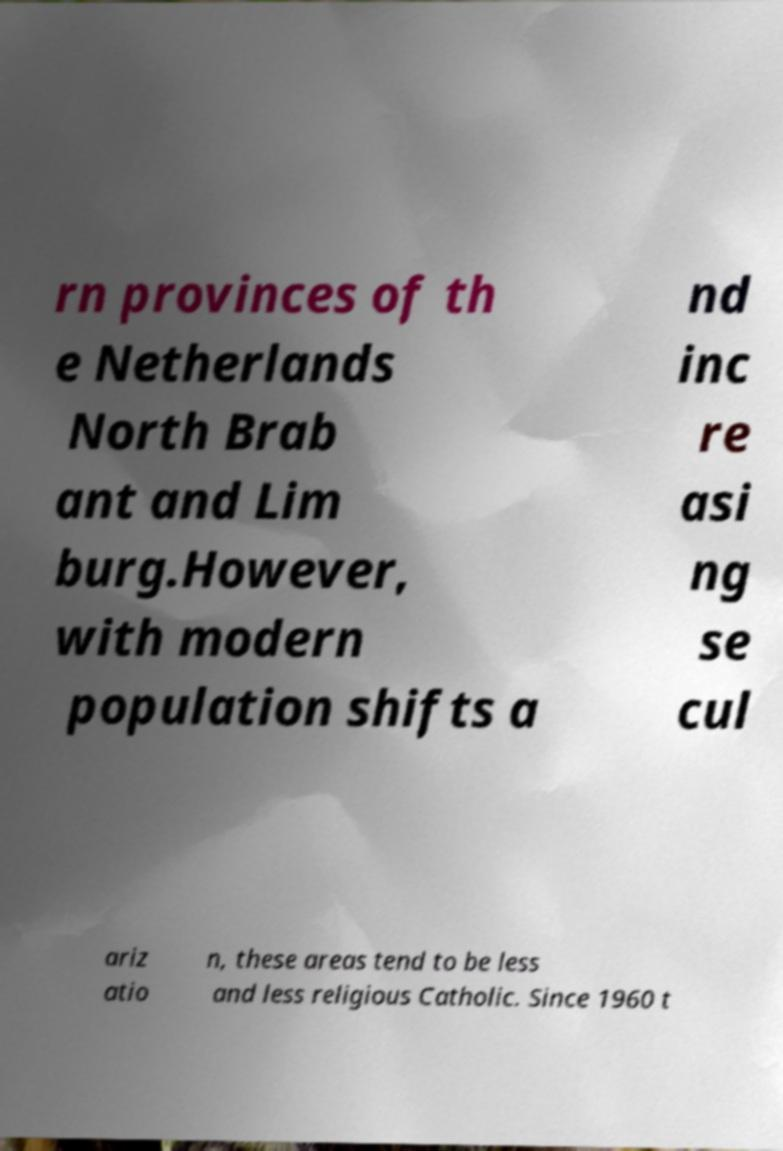Please identify and transcribe the text found in this image. rn provinces of th e Netherlands North Brab ant and Lim burg.However, with modern population shifts a nd inc re asi ng se cul ariz atio n, these areas tend to be less and less religious Catholic. Since 1960 t 